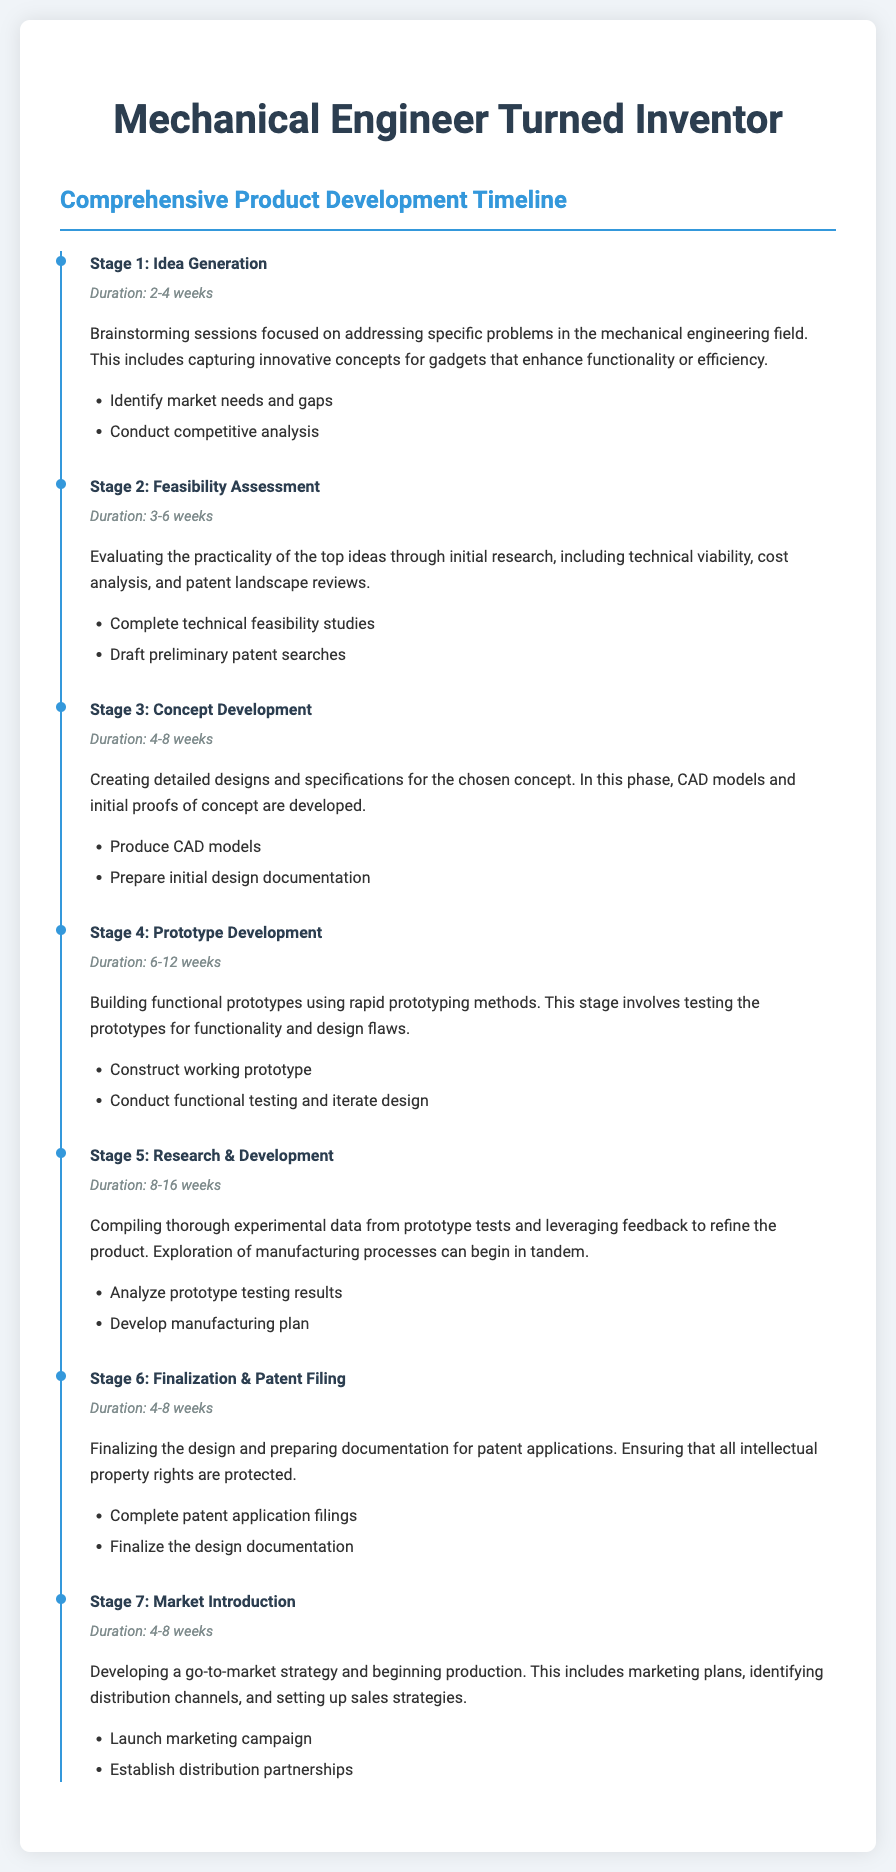what is the duration of Stage 1? The duration of Stage 1, Idea Generation, is mentioned in the document as 2-4 weeks.
Answer: 2-4 weeks what is the focus of Stage 2? The focus of Stage 2, Feasibility Assessment, is evaluating the practicality of the top ideas through initial research.
Answer: Evaluating practicality what is the primary activity in Stage 4? The primary activity in Stage 4, Prototype Development, is to build functional prototypes using rapid prototyping methods.
Answer: Build functional prototypes how long does Stage 5 last? The duration for Stage 5, Research & Development, is specified in the document as 8-16 weeks.
Answer: 8-16 weeks which stage involves patent application filings? The stage involving patent application filings is Stage 6, Finalization & Patent Filing.
Answer: Stage 6 what is one of the tasks during Stage 3? One of the tasks during Stage 3, Concept Development, is to produce CAD models.
Answer: Produce CAD models what is the title of the document? The title of the document is "Mechanical Engineer Turned Inventor Resume".
Answer: Mechanical Engineer Turned Inventor Resume how many weeks does Stage 7 duration range? The duration range for Stage 7, Market Introduction, is 4-8 weeks.
Answer: 4-8 weeks 